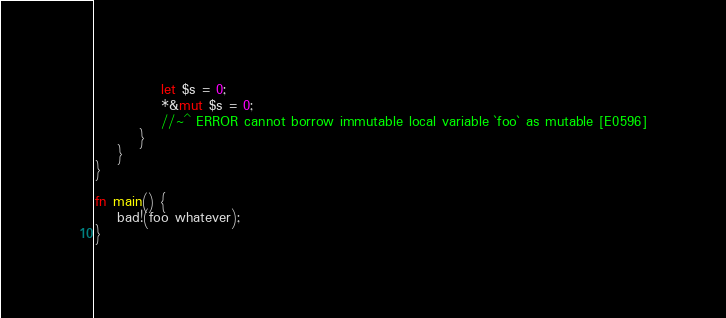Convert code to text. <code><loc_0><loc_0><loc_500><loc_500><_Rust_>            let $s = 0;
            *&mut $s = 0;
            //~^ ERROR cannot borrow immutable local variable `foo` as mutable [E0596]
        }
    }
}

fn main() {
    bad!(foo whatever);
}
</code> 